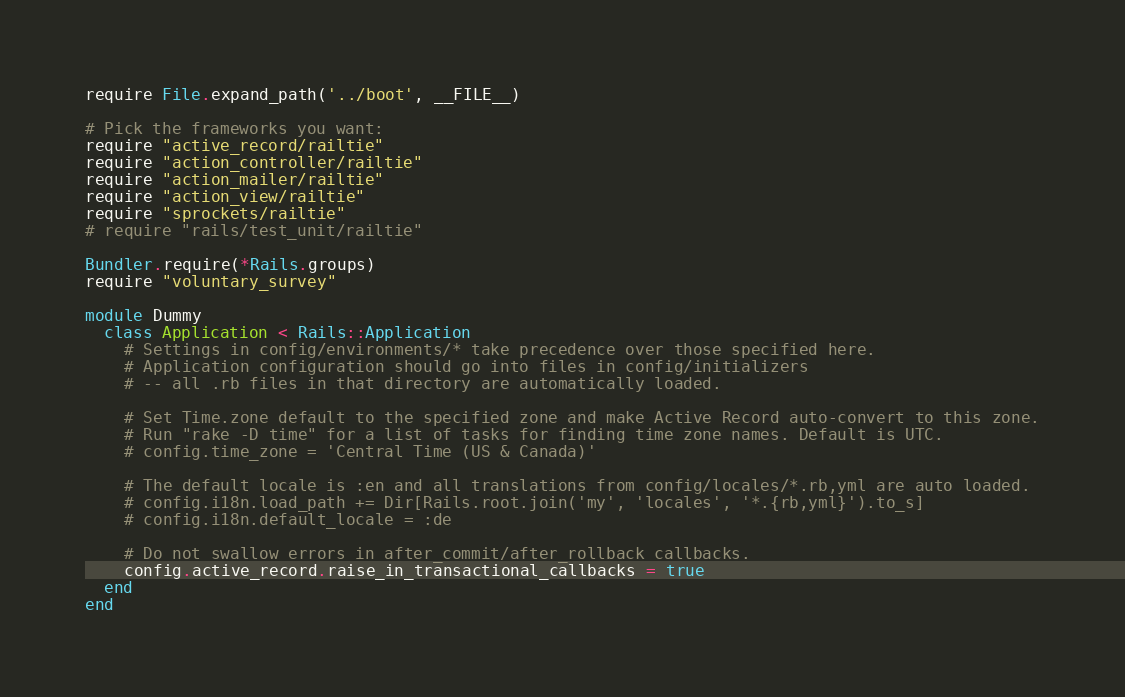<code> <loc_0><loc_0><loc_500><loc_500><_Ruby_>require File.expand_path('../boot', __FILE__)

# Pick the frameworks you want:
require "active_record/railtie"
require "action_controller/railtie"
require "action_mailer/railtie"
require "action_view/railtie"
require "sprockets/railtie"
# require "rails/test_unit/railtie"

Bundler.require(*Rails.groups)
require "voluntary_survey"

module Dummy
  class Application < Rails::Application
    # Settings in config/environments/* take precedence over those specified here.
    # Application configuration should go into files in config/initializers
    # -- all .rb files in that directory are automatically loaded.

    # Set Time.zone default to the specified zone and make Active Record auto-convert to this zone.
    # Run "rake -D time" for a list of tasks for finding time zone names. Default is UTC.
    # config.time_zone = 'Central Time (US & Canada)'

    # The default locale is :en and all translations from config/locales/*.rb,yml are auto loaded.
    # config.i18n.load_path += Dir[Rails.root.join('my', 'locales', '*.{rb,yml}').to_s]
    # config.i18n.default_locale = :de

    # Do not swallow errors in after_commit/after_rollback callbacks.
    config.active_record.raise_in_transactional_callbacks = true
  end
end

</code> 